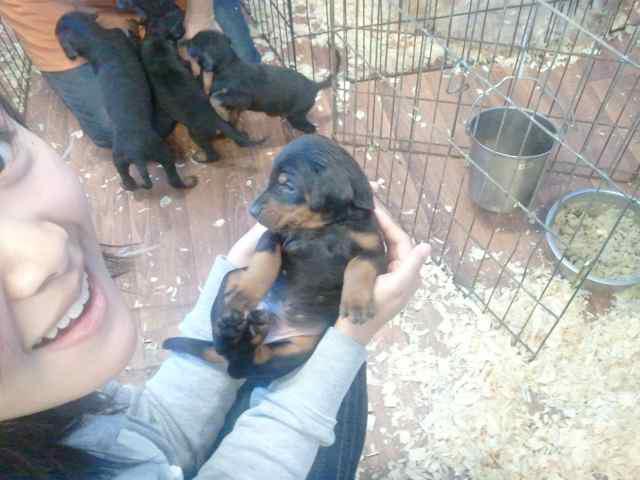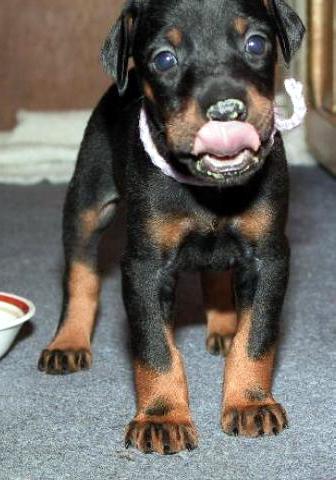The first image is the image on the left, the second image is the image on the right. For the images displayed, is the sentence "The right image features at least two puppies sitting upright with faces forward on a plush white blanket." factually correct? Answer yes or no. No. The first image is the image on the left, the second image is the image on the right. For the images shown, is this caption "At least one of the dogs is standing on all fours." true? Answer yes or no. Yes. 